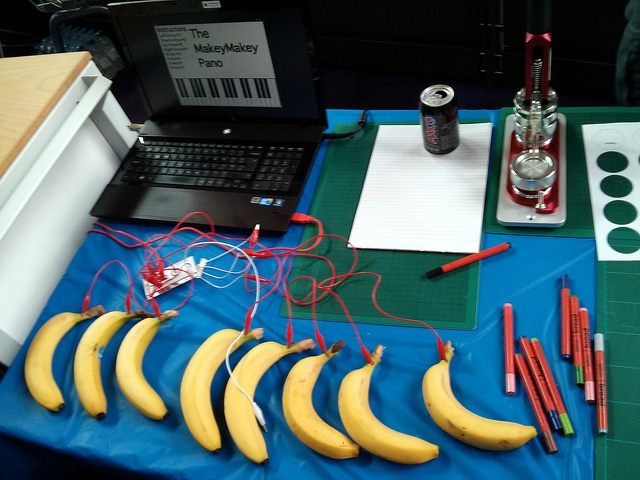Describe the objects in this image and their specific colors. I can see laptop in black, gray, and purple tones, bottle in black, gray, darkgray, and maroon tones, banana in black, gold, tan, orange, and olive tones, banana in black, khaki, tan, and navy tones, and banana in black, gold, olive, tan, and khaki tones in this image. 